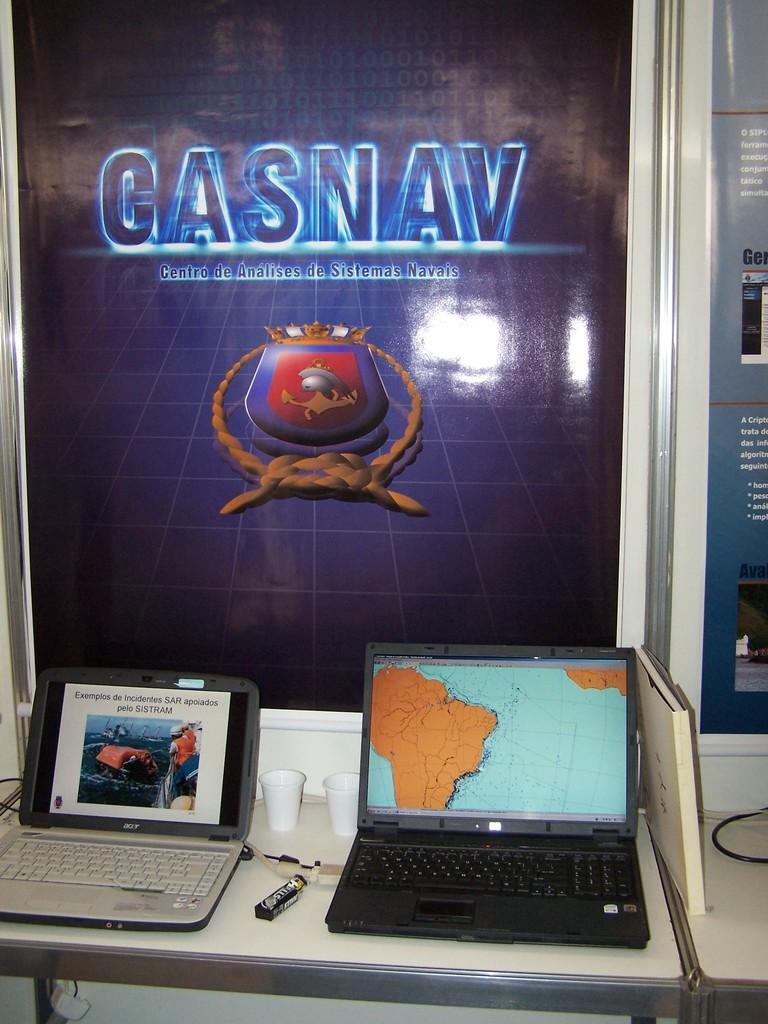Can you describe this image briefly? At the bottom of the image we can see laptops, chocolate and glasses placed on the table. In the background we can see advertisement and wall. 